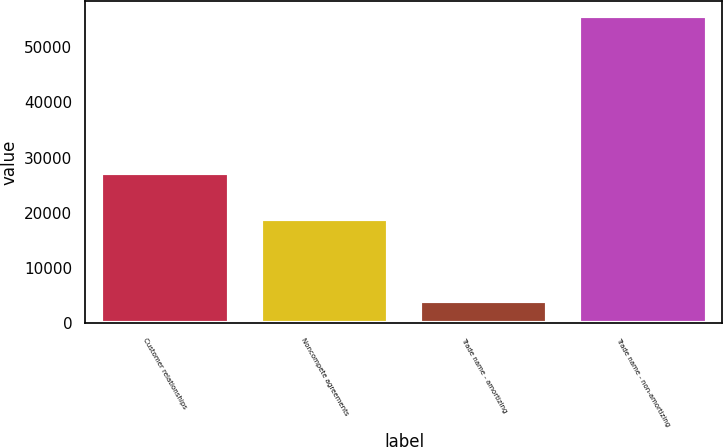Convert chart to OTSL. <chart><loc_0><loc_0><loc_500><loc_500><bar_chart><fcel>Customer relationships<fcel>Noncompete agreements<fcel>Trade name - amortizing<fcel>Trade name - non-amortizing<nl><fcel>27257<fcel>18879<fcel>4050<fcel>55637<nl></chart> 